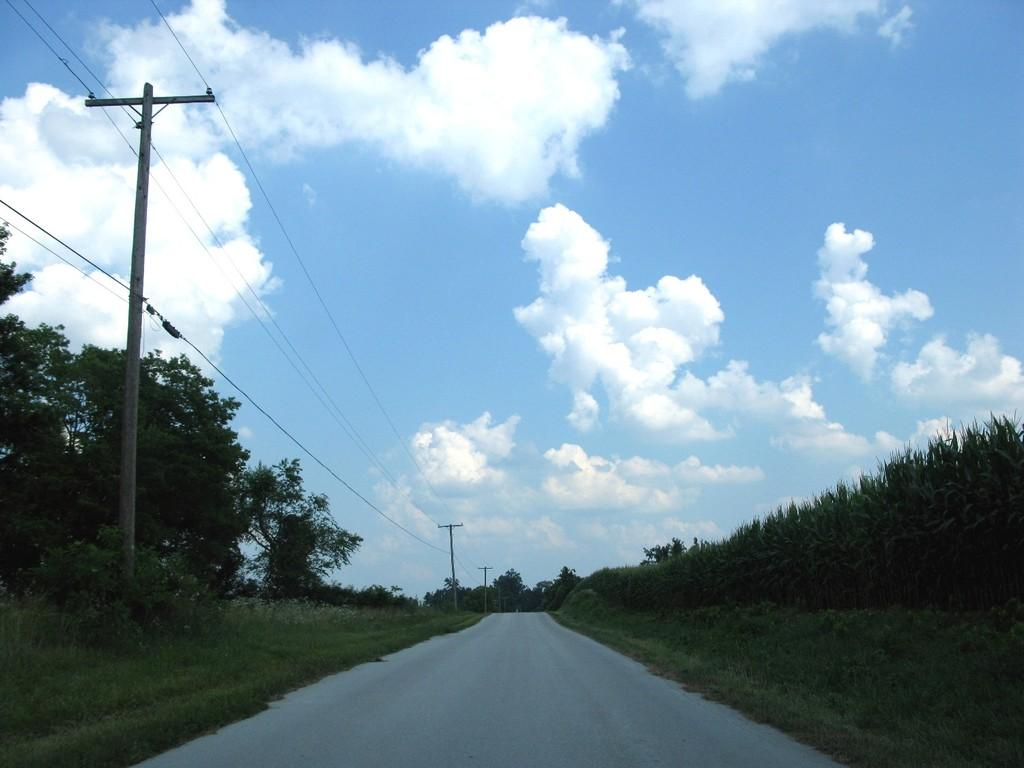What type of vegetation can be seen in the image? There are trees and grass in the image. What type of infrastructure is present in the image? There is a road and electrical poles with wires in the image. What is visible in the background of the image? The sky is visible in the background of the image. What can be seen in the sky? Clouds are present in the sky. What type of heart-shaped pies can be seen on the road in the image? There are no pies, heart-shaped or otherwise, present on the road in the image. Is there a flame visible in the image? There is no flame visible in the image. 